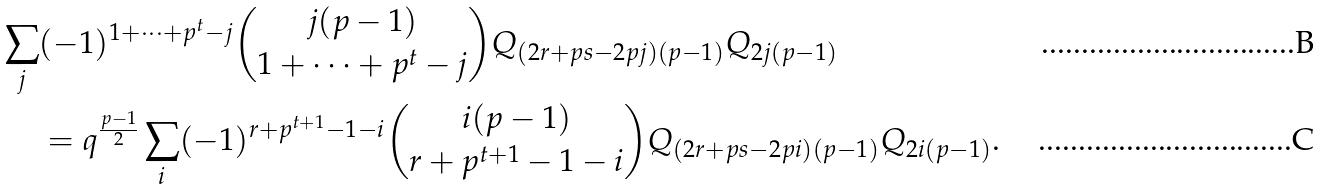Convert formula to latex. <formula><loc_0><loc_0><loc_500><loc_500>\sum _ { j } & ( - 1 ) ^ { 1 + \dots + p ^ { t } - j } \binom { j ( p - 1 ) } { 1 + \dots + p ^ { t } - j } Q _ { ( 2 r + p s - 2 p j ) ( p - 1 ) } Q _ { 2 j ( p - 1 ) } \\ & = q ^ { \frac { p - 1 } { 2 } } \sum _ { i } ( - 1 ) ^ { r + p ^ { t + 1 } - 1 - i } \binom { i ( p - 1 ) } { r + p ^ { t + 1 } - 1 - i } Q _ { ( 2 r + p s - 2 p i ) ( p - 1 ) } Q _ { 2 i ( p - 1 ) } .</formula> 